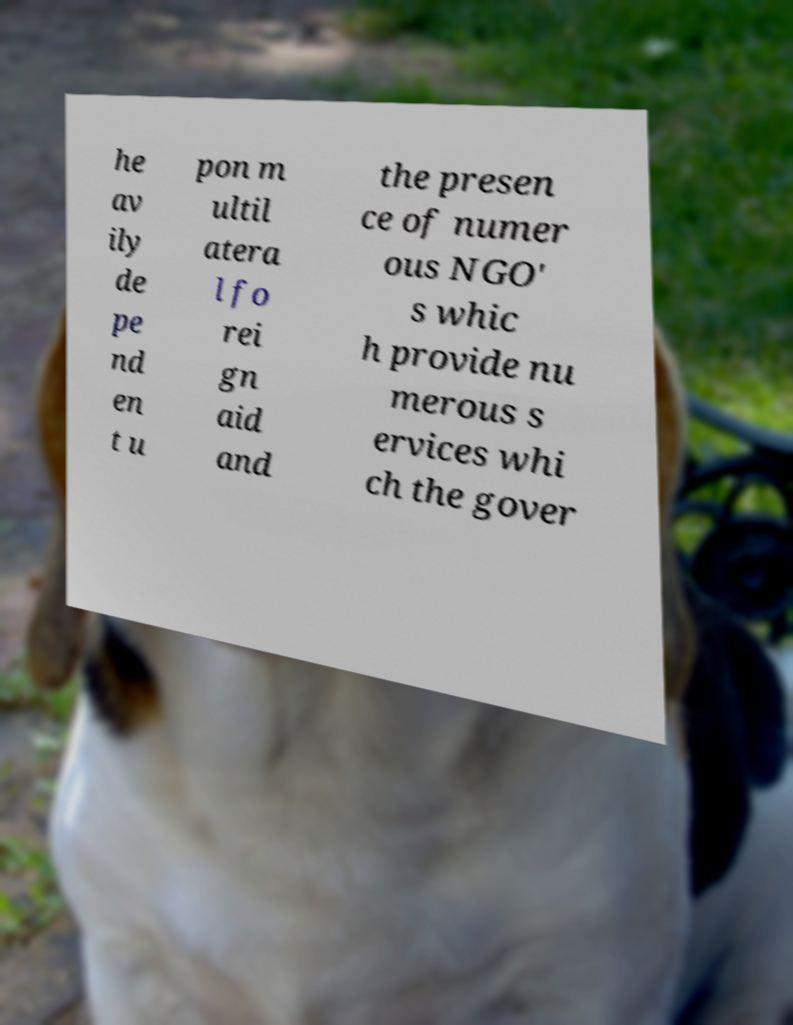For documentation purposes, I need the text within this image transcribed. Could you provide that? he av ily de pe nd en t u pon m ultil atera l fo rei gn aid and the presen ce of numer ous NGO' s whic h provide nu merous s ervices whi ch the gover 